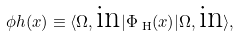<formula> <loc_0><loc_0><loc_500><loc_500>\phi h ( x ) \equiv \langle \Omega , \text {in} | \Phi _ { \text { H} } ( x ) | \Omega , \text {in} \rangle ,</formula> 